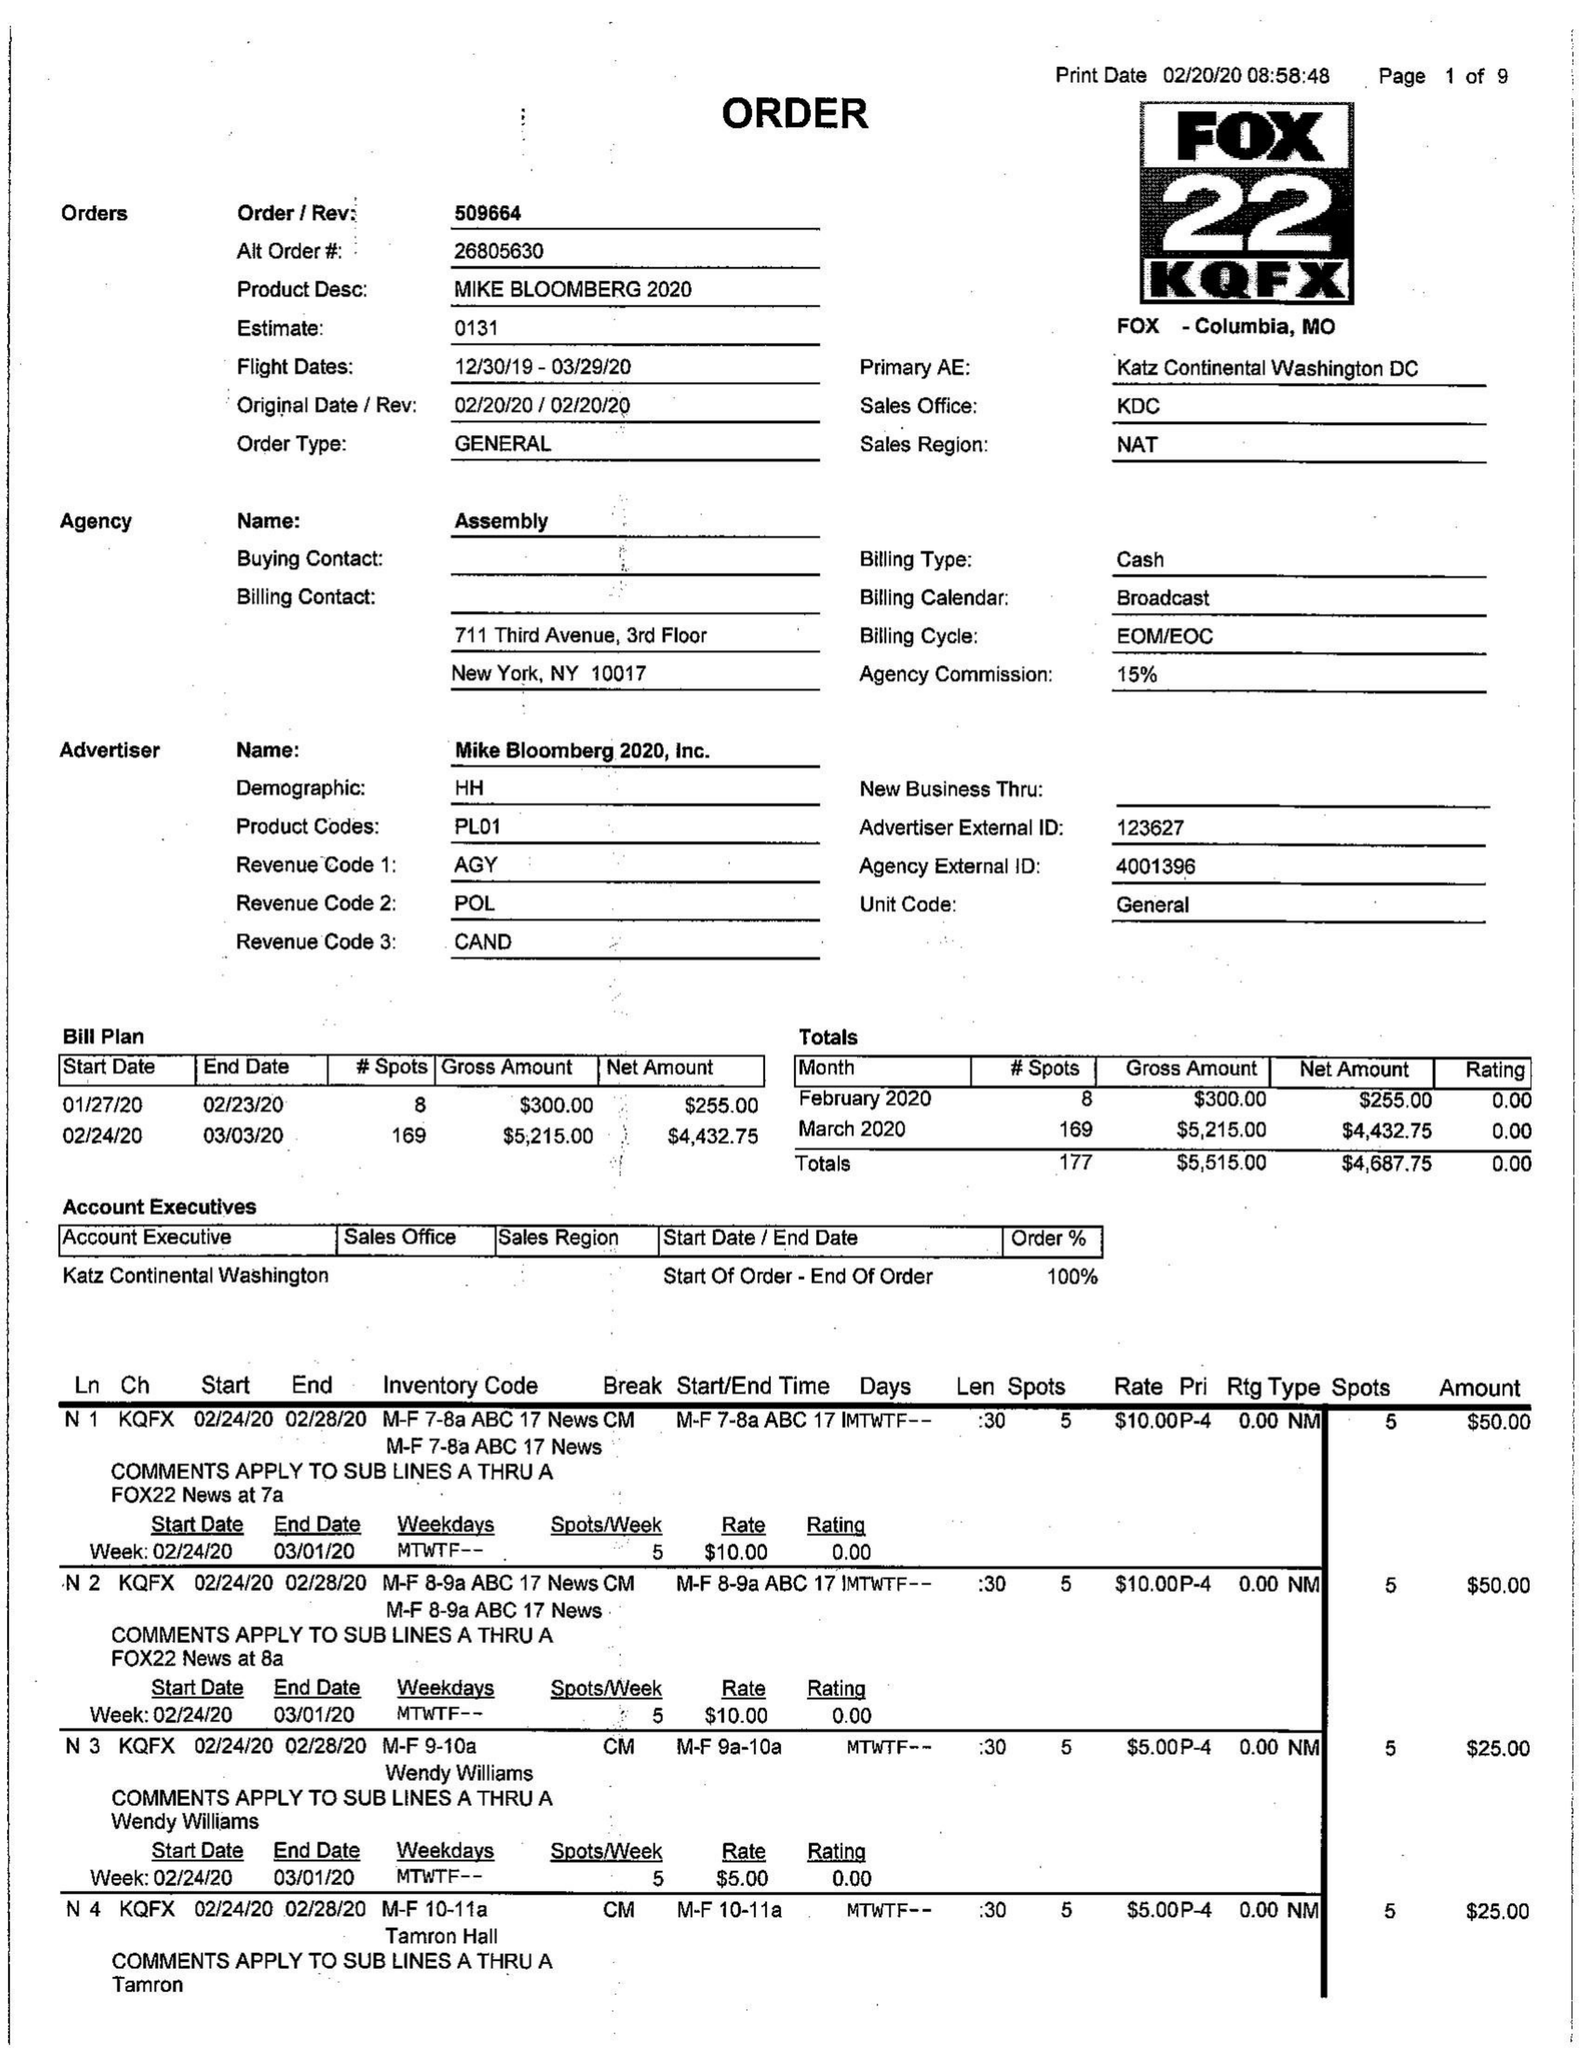What is the value for the contract_num?
Answer the question using a single word or phrase. 509664 